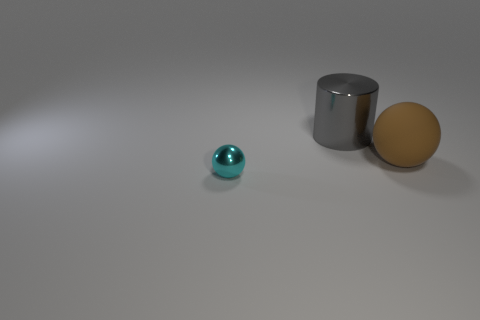There is a sphere that is on the right side of the tiny metallic object; is its color the same as the metal object that is in front of the large gray thing?
Provide a short and direct response. No. What material is the sphere on the right side of the metallic object in front of the shiny thing right of the small metallic sphere?
Your answer should be compact. Rubber. Are there more tiny green metal cylinders than tiny things?
Offer a very short reply. No. Is there any other thing of the same color as the small object?
Give a very brief answer. No. The ball that is made of the same material as the gray cylinder is what size?
Your response must be concise. Small. What material is the small cyan object?
Provide a succinct answer. Metal. What number of brown spheres are the same size as the gray metal cylinder?
Offer a terse response. 1. Are there any other big gray things that have the same shape as the rubber object?
Your answer should be very brief. No. What color is the rubber sphere that is the same size as the gray metal cylinder?
Give a very brief answer. Brown. The metal thing that is in front of the large object behind the rubber ball is what color?
Provide a succinct answer. Cyan. 